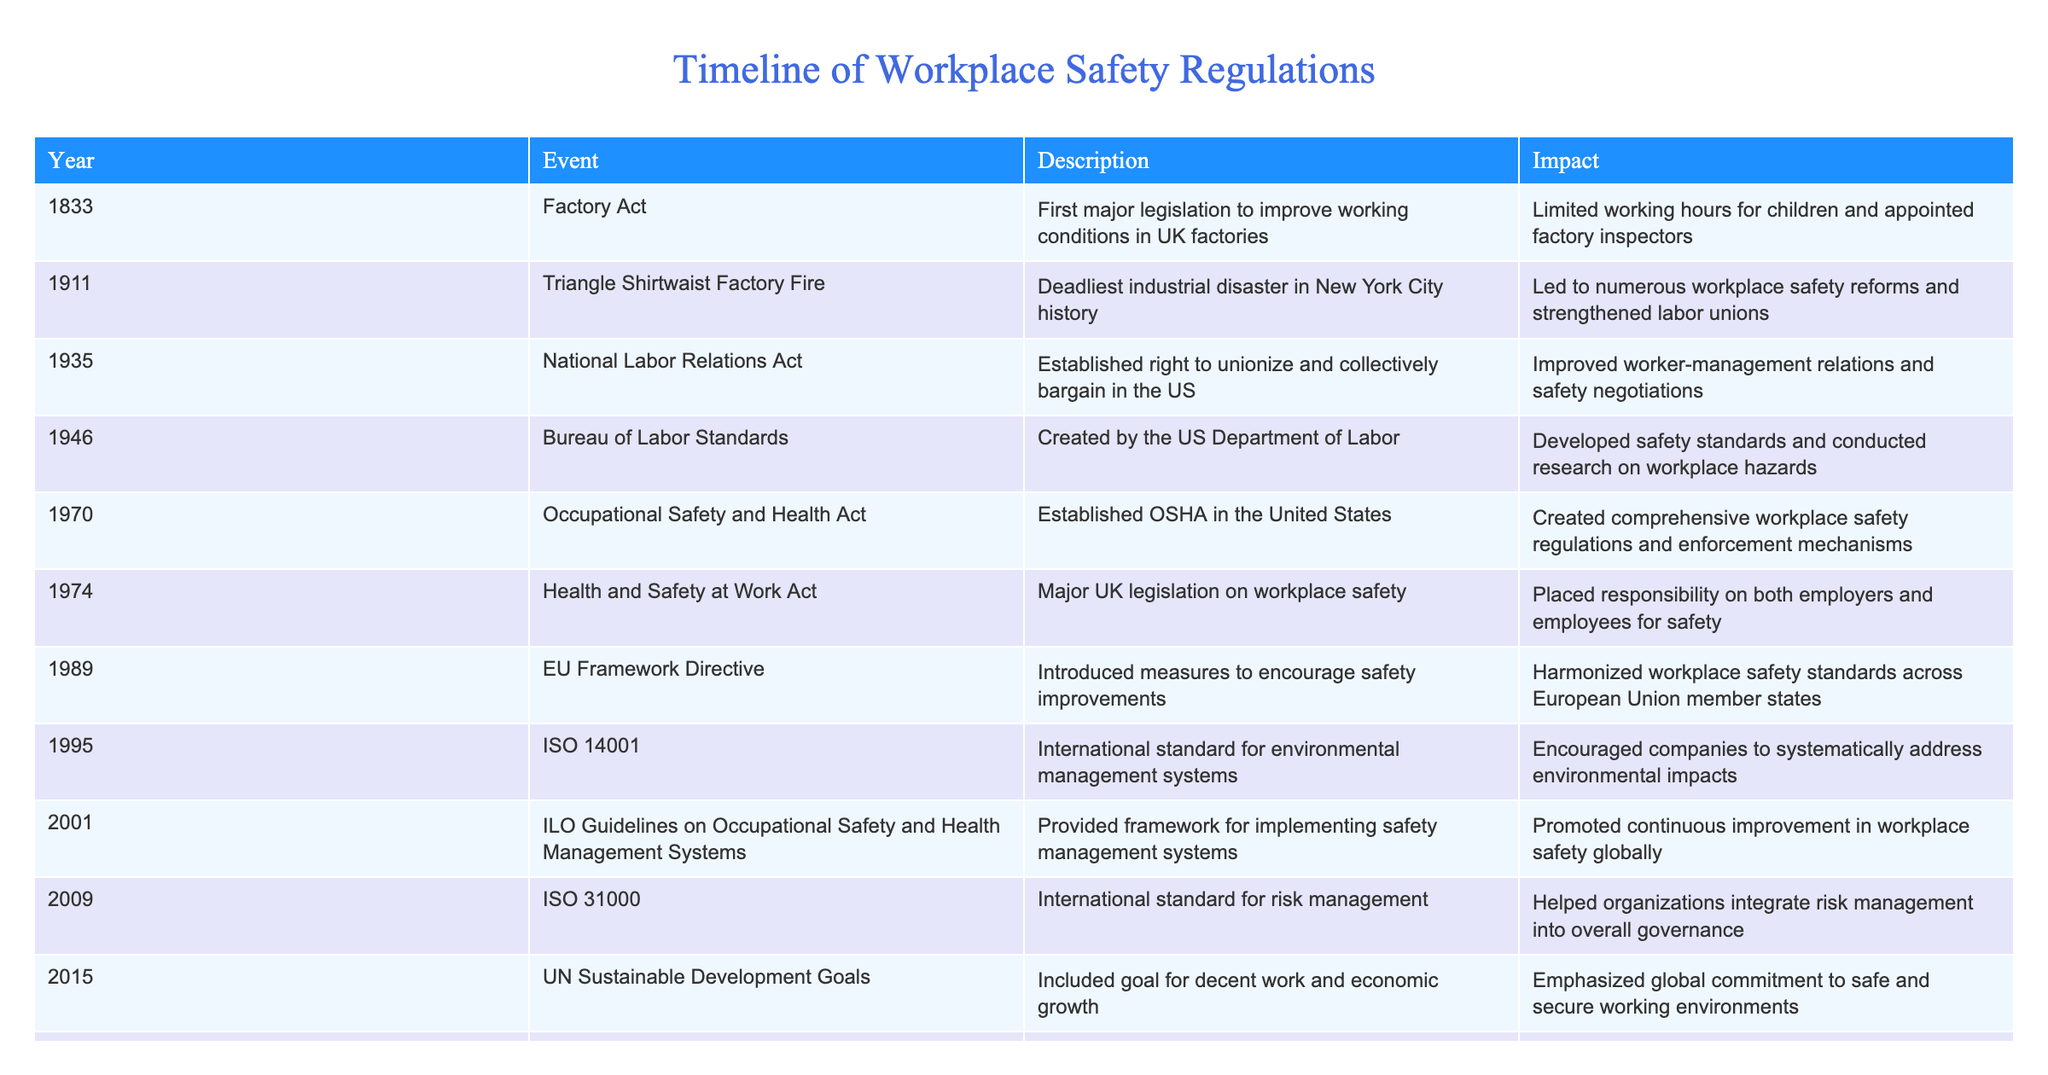What year was the Occupational Safety and Health Act enacted? The table states that the Occupational Safety and Health Act was established in 1970.
Answer: 1970 What impact did the Triangle Shirtwaist Factory Fire have on workplace regulations? According to the table, the Triangle Shirtwaist Factory Fire led to numerous workplace safety reforms and strengthened labor unions.
Answer: Led to safety reforms and strengthened labor unions Which events occurred in the 20th century? List them. From the table, the events in the 20th century are: National Labor Relations Act (1935), Bureau of Labor Standards (1946), Occupational Safety and Health Act (1970), Health and Safety at Work Act (1974), EU Framework Directive (1989), ISO 14001 (1995), ILO Guidelines on Occupational Safety and Health Management Systems (2001), and ISO 31000 (2009).
Answer: National Labor Relations Act (1935), Bureau of Labor Standards (1946), Occupational Safety and Health Act (1970), Health and Safety at Work Act (1974), EU Framework Directive (1989), ISO 14001 (1995), ILO Guidelines (2001), ISO 31000 (2009) Was the UN Sustainable Development Goals related to workplace safety? Yes, the table indicates that the UN Sustainable Development Goals included a goal for decent work and economic growth, emphasizing a commitment to safe working environments.
Answer: Yes What was the chronological order of events from earliest to latest? The chronological order of events based on the table is: 1833 (Factory Act), 1911 (Triangle Shirtwaist Factory Fire), 1935 (National Labor Relations Act), 1946 (Bureau of Labor Standards), 1970 (Occupational Safety and Health Act), 1974 (Health and Safety at Work Act), 1989 (EU Framework Directive), 1995 (ISO 14001), 2001 (ILO Guidelines), 2009 (ISO 31000), 2015 (UN Sustainable Development Goals), and 2020 (COVID-19 Pandemic Response).
Answer: 1833, 1911, 1935, 1946, 1970, 1974, 1989, 1995, 2001, 2009, 2015, 2020 What significant change occurred in 2020 regarding workplace safety? The table states that in 2020, a rapid development of workplace safety protocols for infectious diseases occurred due to the COVID-19 Pandemic Response, which accelerated the adoption of remote work and new safety measures.
Answer: Rapid development of safety protocols for infectious diseases 